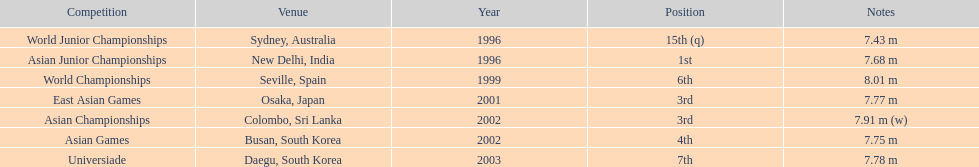How long was huang le's longest jump in 2002? 7.91 m (w). 